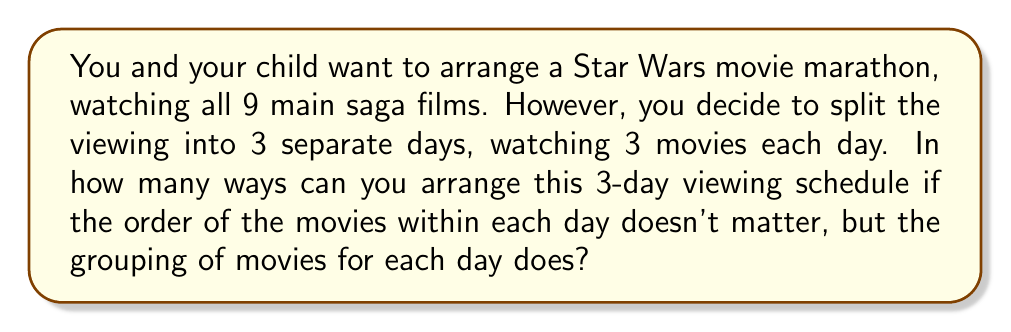Provide a solution to this math problem. Let's approach this step-by-step:

1) First, we need to choose which 3 movies to watch on day 1. This is a combination problem, as the order within the day doesn't matter. We can select 3 movies out of 9, which is represented as $\binom{9}{3}$.

2) After selecting the first day's movies, we have 6 movies left. We need to choose 3 of these for day 2. This is represented as $\binom{6}{3}$.

3) The remaining 3 movies will be watched on day 3. There's only one way to choose these 3 movies, which is $\binom{3}{3} = 1$.

4) By the multiplication principle, the total number of ways to arrange this schedule is:

   $$\binom{9}{3} \cdot \binom{6}{3} \cdot \binom{3}{3}$$

5) Let's calculate each combination:
   
   $\binom{9}{3} = \frac{9!}{3!(9-3)!} = \frac{9!}{3!6!} = 84$
   
   $\binom{6}{3} = \frac{6!}{3!(6-3)!} = \frac{6!}{3!3!} = 20$
   
   $\binom{3}{3} = 1$

6) Therefore, the total number of ways is:

   $$84 \cdot 20 \cdot 1 = 1680$$
Answer: 1680 